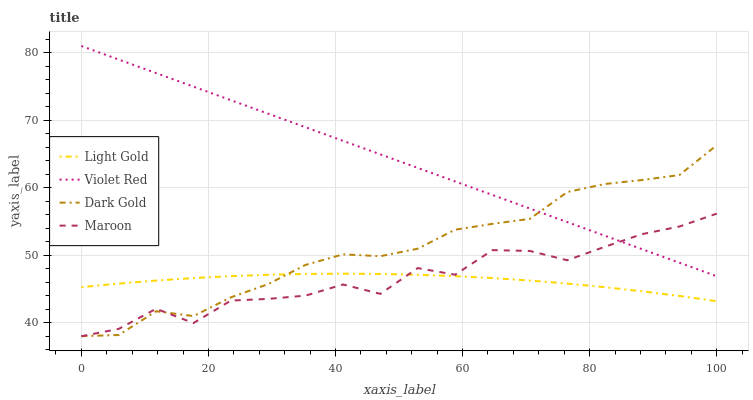Does Light Gold have the minimum area under the curve?
Answer yes or no. Yes. Does Violet Red have the maximum area under the curve?
Answer yes or no. Yes. Does Maroon have the minimum area under the curve?
Answer yes or no. No. Does Maroon have the maximum area under the curve?
Answer yes or no. No. Is Violet Red the smoothest?
Answer yes or no. Yes. Is Maroon the roughest?
Answer yes or no. Yes. Is Light Gold the smoothest?
Answer yes or no. No. Is Light Gold the roughest?
Answer yes or no. No. Does Maroon have the lowest value?
Answer yes or no. Yes. Does Light Gold have the lowest value?
Answer yes or no. No. Does Violet Red have the highest value?
Answer yes or no. Yes. Does Maroon have the highest value?
Answer yes or no. No. Is Light Gold less than Violet Red?
Answer yes or no. Yes. Is Violet Red greater than Light Gold?
Answer yes or no. Yes. Does Violet Red intersect Dark Gold?
Answer yes or no. Yes. Is Violet Red less than Dark Gold?
Answer yes or no. No. Is Violet Red greater than Dark Gold?
Answer yes or no. No. Does Light Gold intersect Violet Red?
Answer yes or no. No. 